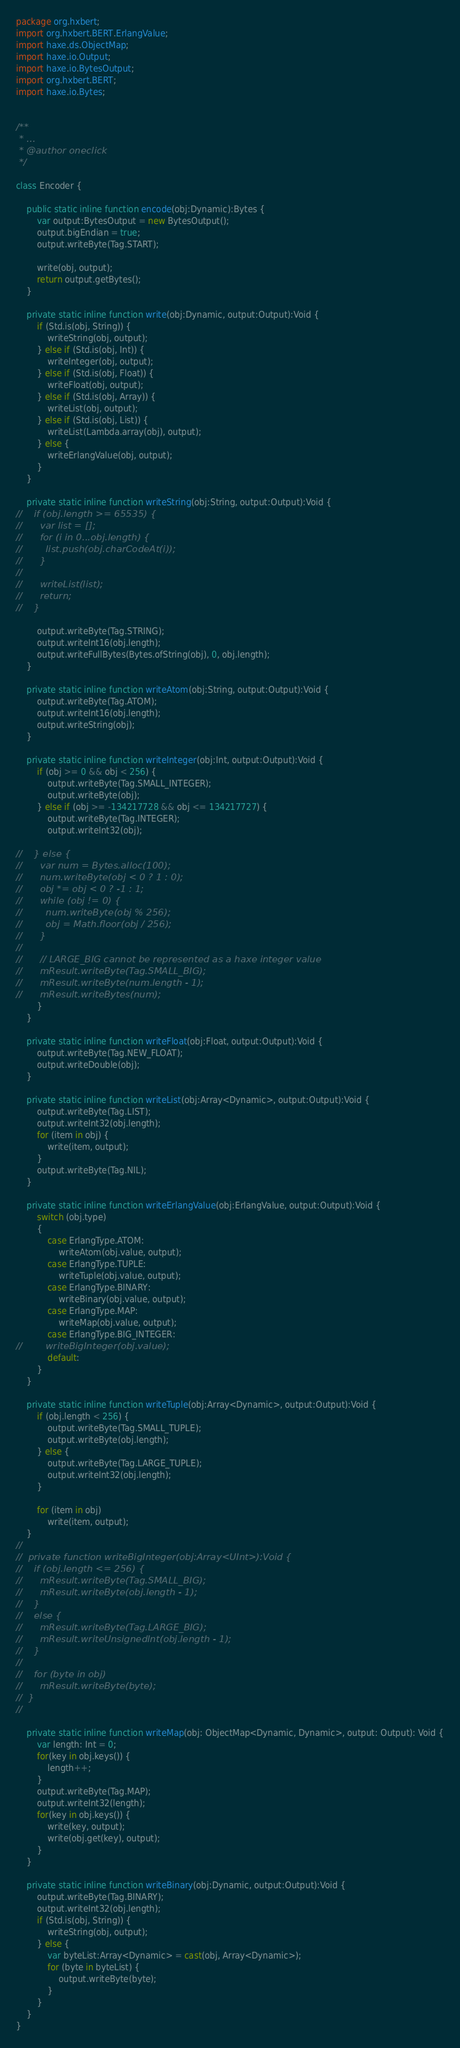<code> <loc_0><loc_0><loc_500><loc_500><_Haxe_>package org.hxbert;
import org.hxbert.BERT.ErlangValue;
import haxe.ds.ObjectMap;
import haxe.io.Output;
import haxe.io.BytesOutput;
import org.hxbert.BERT;
import haxe.io.Bytes;


/**
 * ...
 * @author oneclick
 */

class Encoder {

    public static inline function encode(obj:Dynamic):Bytes {
        var output:BytesOutput = new BytesOutput();
        output.bigEndian = true;
        output.writeByte(Tag.START);

        write(obj, output);
        return output.getBytes();
    }

    private static inline function write(obj:Dynamic, output:Output):Void {
        if (Std.is(obj, String)) {
            writeString(obj, output);
        } else if (Std.is(obj, Int)) {
            writeInteger(obj, output);
        } else if (Std.is(obj, Float)) {
            writeFloat(obj, output);
        } else if (Std.is(obj, Array)) {
            writeList(obj, output);
        } else if (Std.is(obj, List)) {
            writeList(Lambda.array(obj), output);
        } else {
            writeErlangValue(obj, output);
        }
    }

    private static inline function writeString(obj:String, output:Output):Void {
//    if (obj.length >= 65535) {
//      var list = [];
//      for (i in 0...obj.length) {
//        list.push(obj.charCodeAt(i));
//      }
//
//      writeList(list);
//      return;
//    }

        output.writeByte(Tag.STRING);
        output.writeInt16(obj.length);
        output.writeFullBytes(Bytes.ofString(obj), 0, obj.length);
    }

    private static inline function writeAtom(obj:String, output:Output):Void {
        output.writeByte(Tag.ATOM);
        output.writeInt16(obj.length);
        output.writeString(obj);
    }

    private static inline function writeInteger(obj:Int, output:Output):Void {
        if (obj >= 0 && obj < 256) {
            output.writeByte(Tag.SMALL_INTEGER);
            output.writeByte(obj);
        } else if (obj >= -134217728 && obj <= 134217727) {
            output.writeByte(Tag.INTEGER);
            output.writeInt32(obj);

//    } else {
//      var num = Bytes.alloc(100);
//      num.writeByte(obj < 0 ? 1 : 0);
//      obj *= obj < 0 ? -1 : 1;
//      while (obj != 0) {
//        num.writeByte(obj % 256);
//        obj = Math.floor(obj / 256);
//      }
//
//      // LARGE_BIG cannot be represented as a haxe integer value
//      mResult.writeByte(Tag.SMALL_BIG);
//      mResult.writeByte(num.length - 1);
//      mResult.writeBytes(num);
        }
    }

    private static inline function writeFloat(obj:Float, output:Output):Void {
        output.writeByte(Tag.NEW_FLOAT);
        output.writeDouble(obj);
    }

    private static inline function writeList(obj:Array<Dynamic>, output:Output):Void {
        output.writeByte(Tag.LIST);
        output.writeInt32(obj.length);
        for (item in obj) {
            write(item, output);
        }
        output.writeByte(Tag.NIL);
    }

    private static inline function writeErlangValue(obj:ErlangValue, output:Output):Void {
        switch (obj.type)
        {
            case ErlangType.ATOM:
                writeAtom(obj.value, output);
            case ErlangType.TUPLE:
                writeTuple(obj.value, output);
            case ErlangType.BINARY:
                writeBinary(obj.value, output);
            case ErlangType.MAP:
                writeMap(obj.value, output);
            case ErlangType.BIG_INTEGER:
//        writeBigInteger(obj.value);
            default:
        }
    }

    private static inline function writeTuple(obj:Array<Dynamic>, output:Output):Void {
        if (obj.length < 256) {
            output.writeByte(Tag.SMALL_TUPLE);
            output.writeByte(obj.length);
        } else {
            output.writeByte(Tag.LARGE_TUPLE);
            output.writeInt32(obj.length);
        }

        for (item in obj)
            write(item, output);
    }
//
//  private function writeBigInteger(obj:Array<UInt>):Void {
//    if (obj.length <= 256) {
//      mResult.writeByte(Tag.SMALL_BIG);
//      mResult.writeByte(obj.length - 1);
//    }
//    else {
//      mResult.writeByte(Tag.LARGE_BIG);
//      mResult.writeUnsignedInt(obj.length - 1);
//    }
//
//    for (byte in obj)
//      mResult.writeByte(byte);
//  }
//

    private static inline function writeMap(obj: ObjectMap<Dynamic, Dynamic>, output: Output): Void {
        var length: Int = 0;
        for(key in obj.keys()) {
            length++;
        }
        output.writeByte(Tag.MAP);
        output.writeInt32(length);
        for(key in obj.keys()) {
            write(key, output);
            write(obj.get(key), output);
        }
    }

    private static inline function writeBinary(obj:Dynamic, output:Output):Void {
        output.writeByte(Tag.BINARY);
        output.writeInt32(obj.length);
        if (Std.is(obj, String)) {
            writeString(obj, output);
        } else {
            var byteList:Array<Dynamic> = cast(obj, Array<Dynamic>);
            for (byte in byteList) {
                output.writeByte(byte);
            }
        }
    }
}</code> 